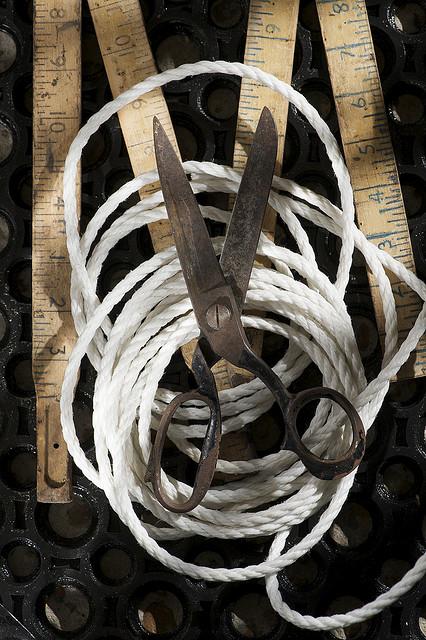What in photo could be cut with the scissors?
Write a very short answer. Rope. What is the sharp object?
Write a very short answer. Scissors. How many rulers are shown?
Concise answer only. 4. 